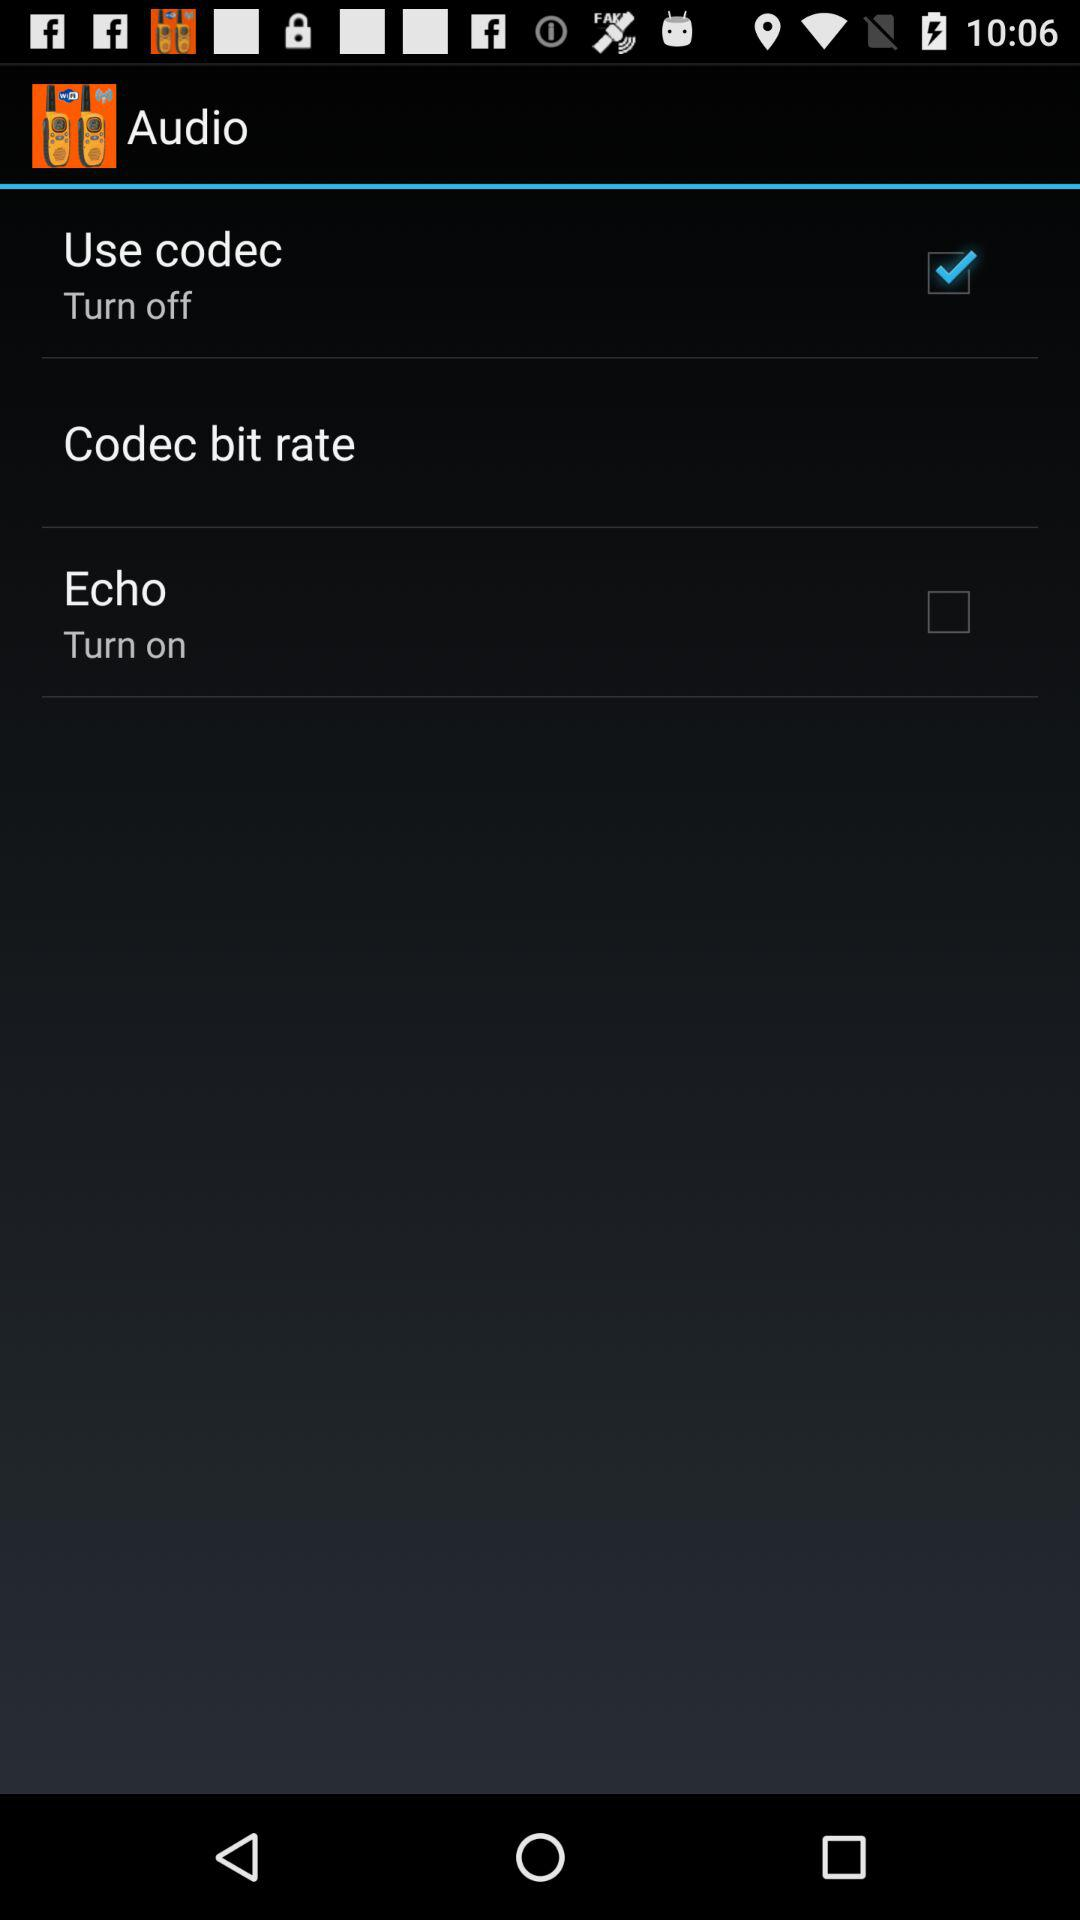What is the status of echo? The status is off. 